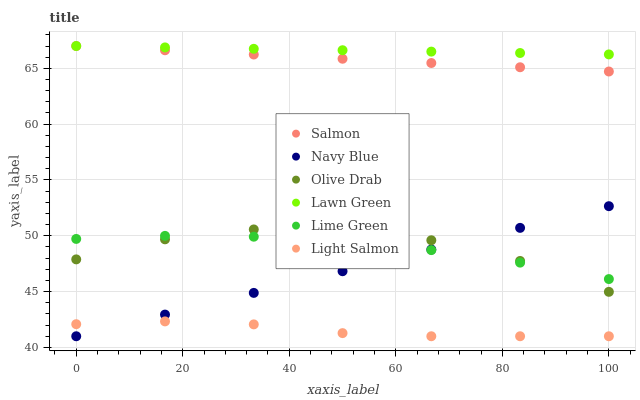Does Light Salmon have the minimum area under the curve?
Answer yes or no. Yes. Does Lawn Green have the maximum area under the curve?
Answer yes or no. Yes. Does Navy Blue have the minimum area under the curve?
Answer yes or no. No. Does Navy Blue have the maximum area under the curve?
Answer yes or no. No. Is Navy Blue the smoothest?
Answer yes or no. Yes. Is Olive Drab the roughest?
Answer yes or no. Yes. Is Light Salmon the smoothest?
Answer yes or no. No. Is Light Salmon the roughest?
Answer yes or no. No. Does Light Salmon have the lowest value?
Answer yes or no. Yes. Does Salmon have the lowest value?
Answer yes or no. No. Does Salmon have the highest value?
Answer yes or no. Yes. Does Navy Blue have the highest value?
Answer yes or no. No. Is Lime Green less than Lawn Green?
Answer yes or no. Yes. Is Lawn Green greater than Light Salmon?
Answer yes or no. Yes. Does Lime Green intersect Olive Drab?
Answer yes or no. Yes. Is Lime Green less than Olive Drab?
Answer yes or no. No. Is Lime Green greater than Olive Drab?
Answer yes or no. No. Does Lime Green intersect Lawn Green?
Answer yes or no. No. 